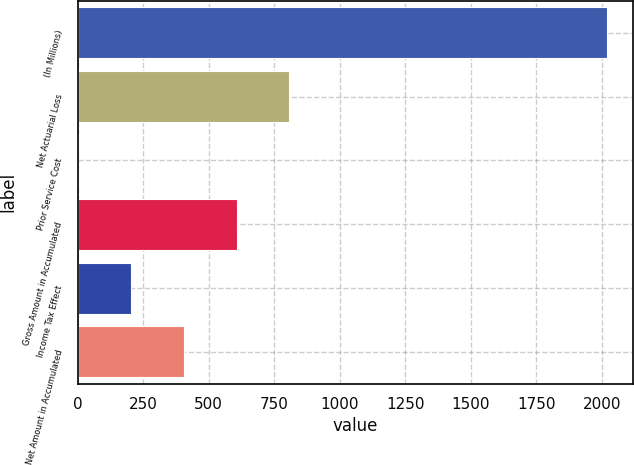Convert chart to OTSL. <chart><loc_0><loc_0><loc_500><loc_500><bar_chart><fcel>(In Millions)<fcel>Net Actuarial Loss<fcel>Prior Service Cost<fcel>Gross Amount in Accumulated<fcel>Income Tax Effect<fcel>Net Amount in Accumulated<nl><fcel>2018<fcel>808.04<fcel>1.4<fcel>606.38<fcel>203.06<fcel>404.72<nl></chart> 